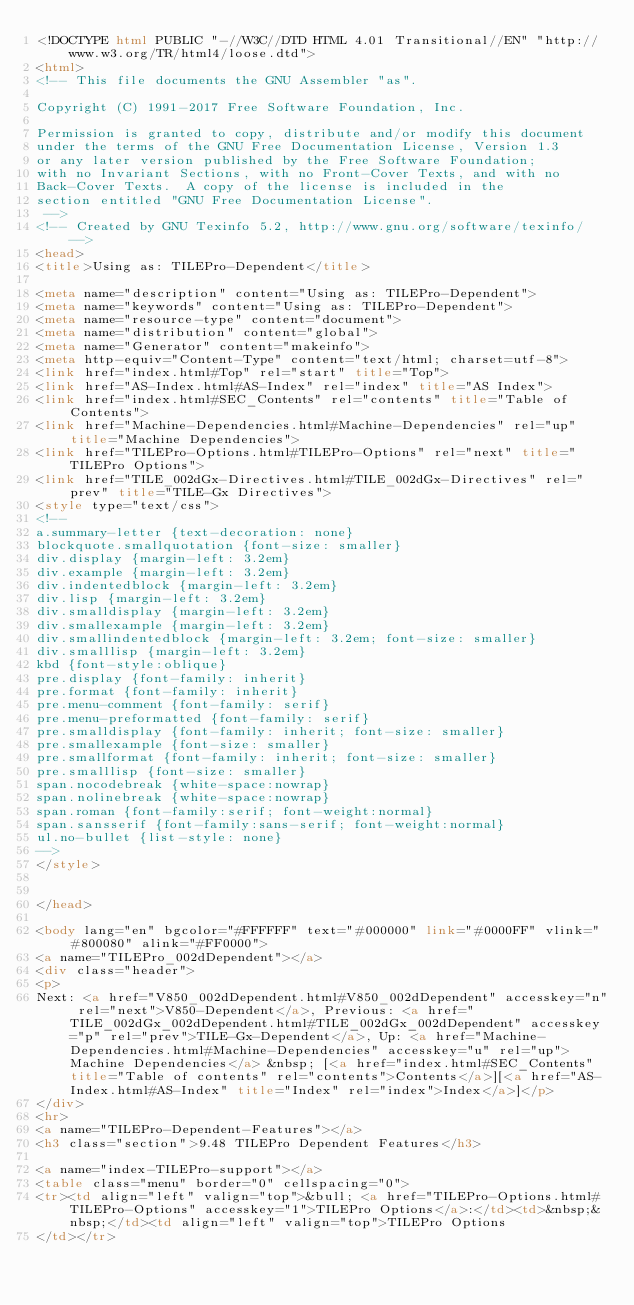<code> <loc_0><loc_0><loc_500><loc_500><_HTML_><!DOCTYPE html PUBLIC "-//W3C//DTD HTML 4.01 Transitional//EN" "http://www.w3.org/TR/html4/loose.dtd">
<html>
<!-- This file documents the GNU Assembler "as".

Copyright (C) 1991-2017 Free Software Foundation, Inc.

Permission is granted to copy, distribute and/or modify this document
under the terms of the GNU Free Documentation License, Version 1.3
or any later version published by the Free Software Foundation;
with no Invariant Sections, with no Front-Cover Texts, and with no
Back-Cover Texts.  A copy of the license is included in the
section entitled "GNU Free Documentation License".
 -->
<!-- Created by GNU Texinfo 5.2, http://www.gnu.org/software/texinfo/ -->
<head>
<title>Using as: TILEPro-Dependent</title>

<meta name="description" content="Using as: TILEPro-Dependent">
<meta name="keywords" content="Using as: TILEPro-Dependent">
<meta name="resource-type" content="document">
<meta name="distribution" content="global">
<meta name="Generator" content="makeinfo">
<meta http-equiv="Content-Type" content="text/html; charset=utf-8">
<link href="index.html#Top" rel="start" title="Top">
<link href="AS-Index.html#AS-Index" rel="index" title="AS Index">
<link href="index.html#SEC_Contents" rel="contents" title="Table of Contents">
<link href="Machine-Dependencies.html#Machine-Dependencies" rel="up" title="Machine Dependencies">
<link href="TILEPro-Options.html#TILEPro-Options" rel="next" title="TILEPro Options">
<link href="TILE_002dGx-Directives.html#TILE_002dGx-Directives" rel="prev" title="TILE-Gx Directives">
<style type="text/css">
<!--
a.summary-letter {text-decoration: none}
blockquote.smallquotation {font-size: smaller}
div.display {margin-left: 3.2em}
div.example {margin-left: 3.2em}
div.indentedblock {margin-left: 3.2em}
div.lisp {margin-left: 3.2em}
div.smalldisplay {margin-left: 3.2em}
div.smallexample {margin-left: 3.2em}
div.smallindentedblock {margin-left: 3.2em; font-size: smaller}
div.smalllisp {margin-left: 3.2em}
kbd {font-style:oblique}
pre.display {font-family: inherit}
pre.format {font-family: inherit}
pre.menu-comment {font-family: serif}
pre.menu-preformatted {font-family: serif}
pre.smalldisplay {font-family: inherit; font-size: smaller}
pre.smallexample {font-size: smaller}
pre.smallformat {font-family: inherit; font-size: smaller}
pre.smalllisp {font-size: smaller}
span.nocodebreak {white-space:nowrap}
span.nolinebreak {white-space:nowrap}
span.roman {font-family:serif; font-weight:normal}
span.sansserif {font-family:sans-serif; font-weight:normal}
ul.no-bullet {list-style: none}
-->
</style>


</head>

<body lang="en" bgcolor="#FFFFFF" text="#000000" link="#0000FF" vlink="#800080" alink="#FF0000">
<a name="TILEPro_002dDependent"></a>
<div class="header">
<p>
Next: <a href="V850_002dDependent.html#V850_002dDependent" accesskey="n" rel="next">V850-Dependent</a>, Previous: <a href="TILE_002dGx_002dDependent.html#TILE_002dGx_002dDependent" accesskey="p" rel="prev">TILE-Gx-Dependent</a>, Up: <a href="Machine-Dependencies.html#Machine-Dependencies" accesskey="u" rel="up">Machine Dependencies</a> &nbsp; [<a href="index.html#SEC_Contents" title="Table of contents" rel="contents">Contents</a>][<a href="AS-Index.html#AS-Index" title="Index" rel="index">Index</a>]</p>
</div>
<hr>
<a name="TILEPro-Dependent-Features"></a>
<h3 class="section">9.48 TILEPro Dependent Features</h3>

<a name="index-TILEPro-support"></a>
<table class="menu" border="0" cellspacing="0">
<tr><td align="left" valign="top">&bull; <a href="TILEPro-Options.html#TILEPro-Options" accesskey="1">TILEPro Options</a>:</td><td>&nbsp;&nbsp;</td><td align="left" valign="top">TILEPro Options
</td></tr></code> 